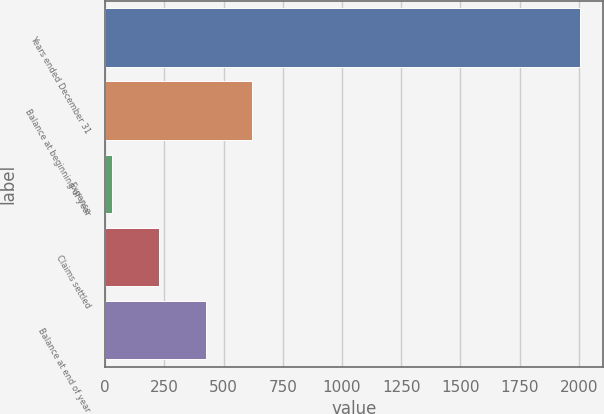Convert chart. <chart><loc_0><loc_0><loc_500><loc_500><bar_chart><fcel>Years ended December 31<fcel>Balance at beginning of year<fcel>Expense<fcel>Claims settled<fcel>Balance at end of year<nl><fcel>2003<fcel>621.27<fcel>29.1<fcel>226.49<fcel>423.88<nl></chart> 